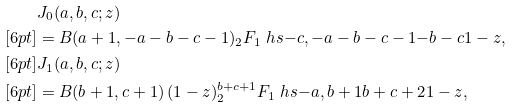Convert formula to latex. <formula><loc_0><loc_0><loc_500><loc_500>& J _ { 0 } ( a , b , c ; z ) \\ [ 6 p t ] & = B ( a + 1 , - a - b - c - 1 ) _ { 2 } F _ { 1 } \ h s { - c , - a - b - c - 1 } { - b - c } { 1 - z } , \\ [ 6 p t ] & J _ { 1 } ( a , b , c ; z ) \\ [ 6 p t ] & = B ( b + 1 , c + 1 ) \, ( 1 - z ) ^ { b + c + 1 } _ { 2 } F _ { 1 } \ h s { - a , b + 1 } { b + c + 2 } { 1 - z } ,</formula> 